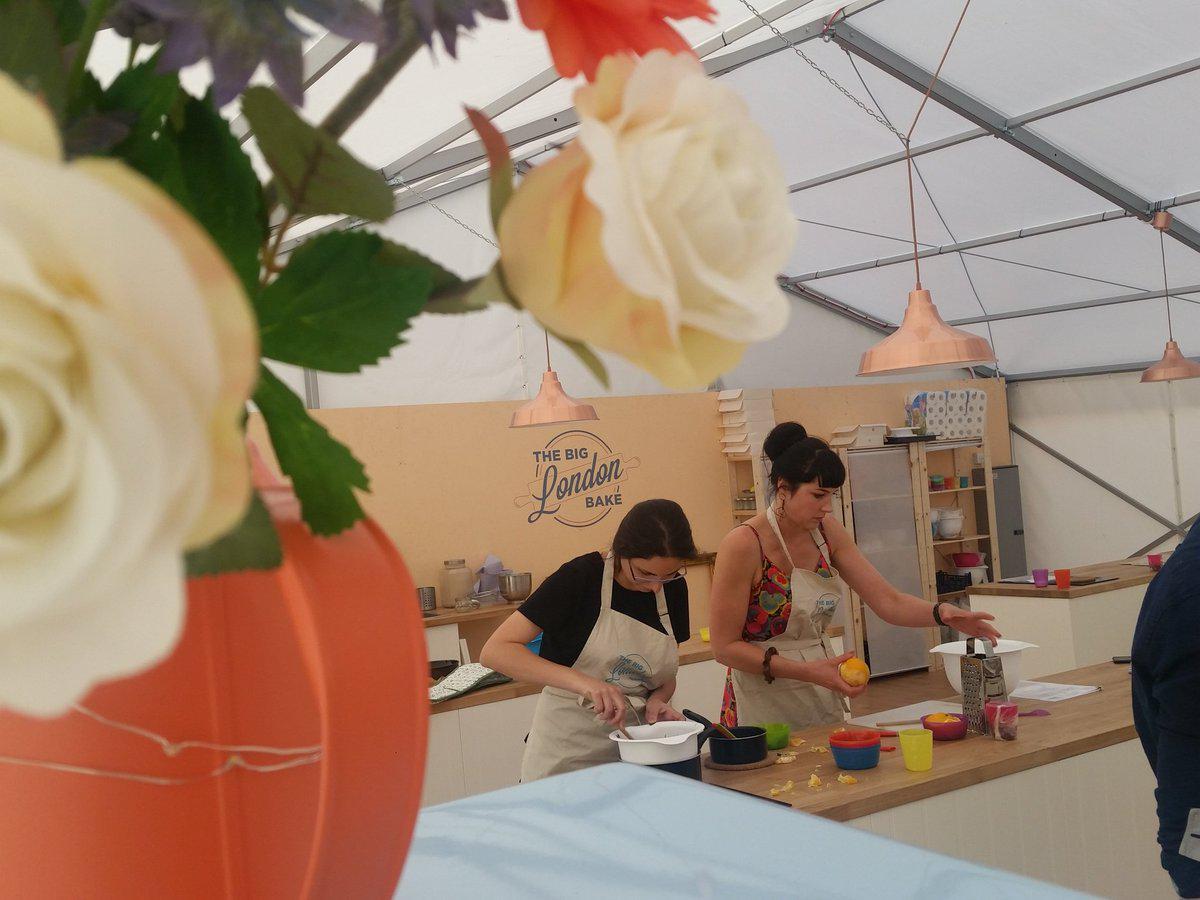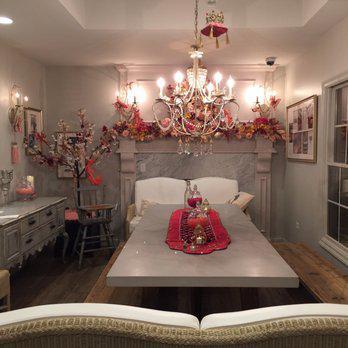The first image is the image on the left, the second image is the image on the right. For the images displayed, is the sentence "There is a chalkboard with writing on it." factually correct? Answer yes or no. No. The first image is the image on the left, the second image is the image on the right. For the images shown, is this caption "The left image includes a baked item displayed on a pedestal." true? Answer yes or no. No. 